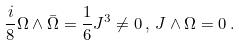Convert formula to latex. <formula><loc_0><loc_0><loc_500><loc_500>\frac { i } { 8 } \Omega \wedge \bar { \Omega } = \frac { 1 } { 6 } J ^ { 3 } \neq 0 \, , \, J \wedge \Omega = 0 \, .</formula> 